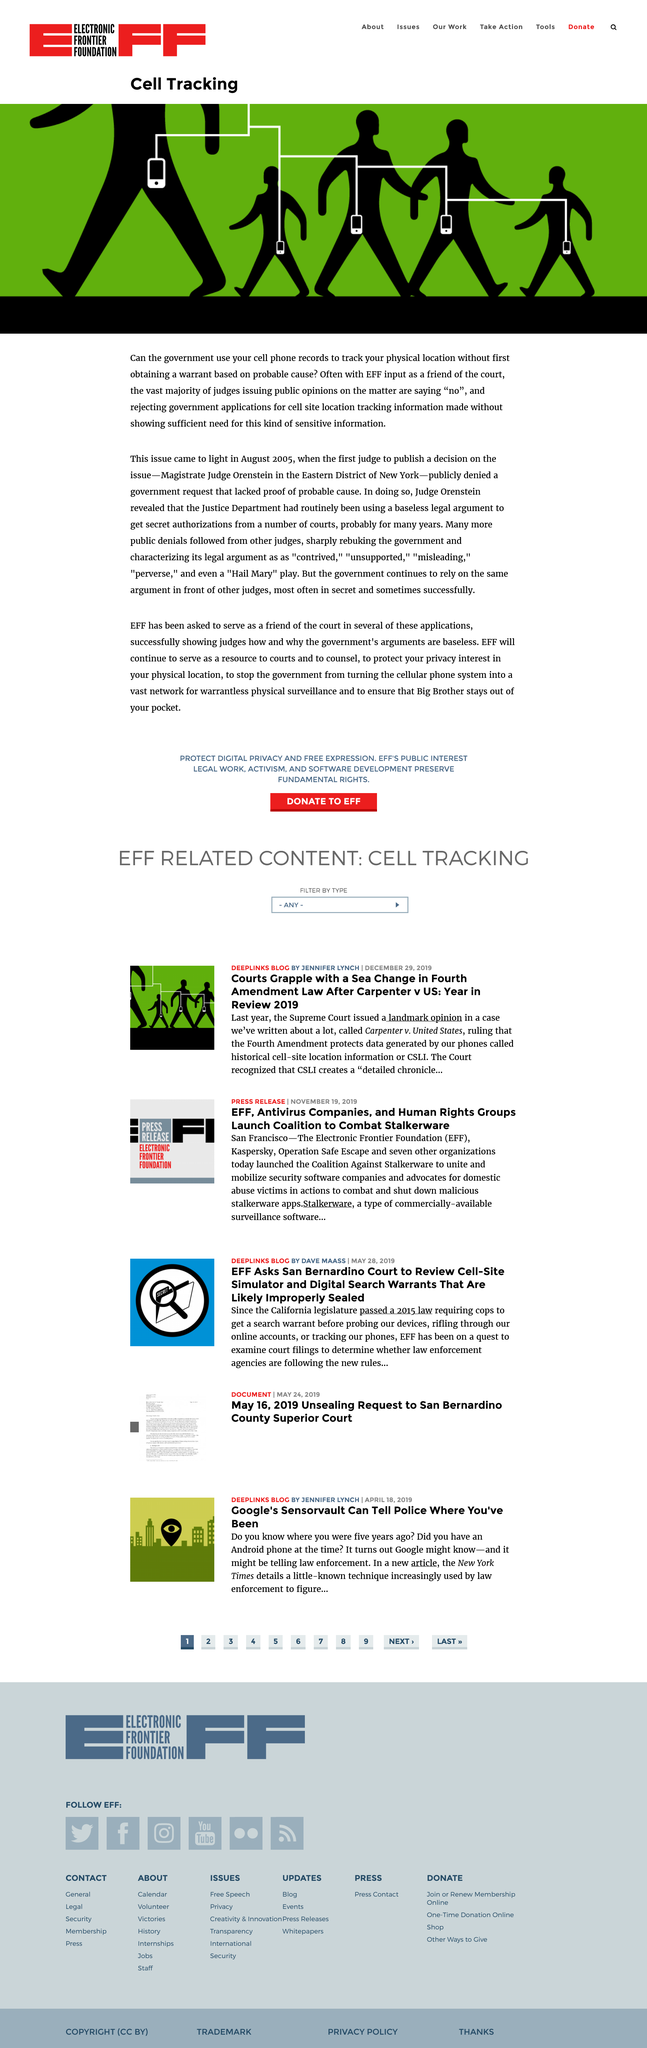Point out several critical features in this image. The Electronic Frontier Foundation, also known as the EFF, serves as a friend of the court in providing input on legal matters. The issue of the government using cell phone records to track people's physical location without first obtaining a warrant was first brought to light in August 2005. Judge Orenstein revealed that the Justice Department had been using a baseless legal argument routinely. 